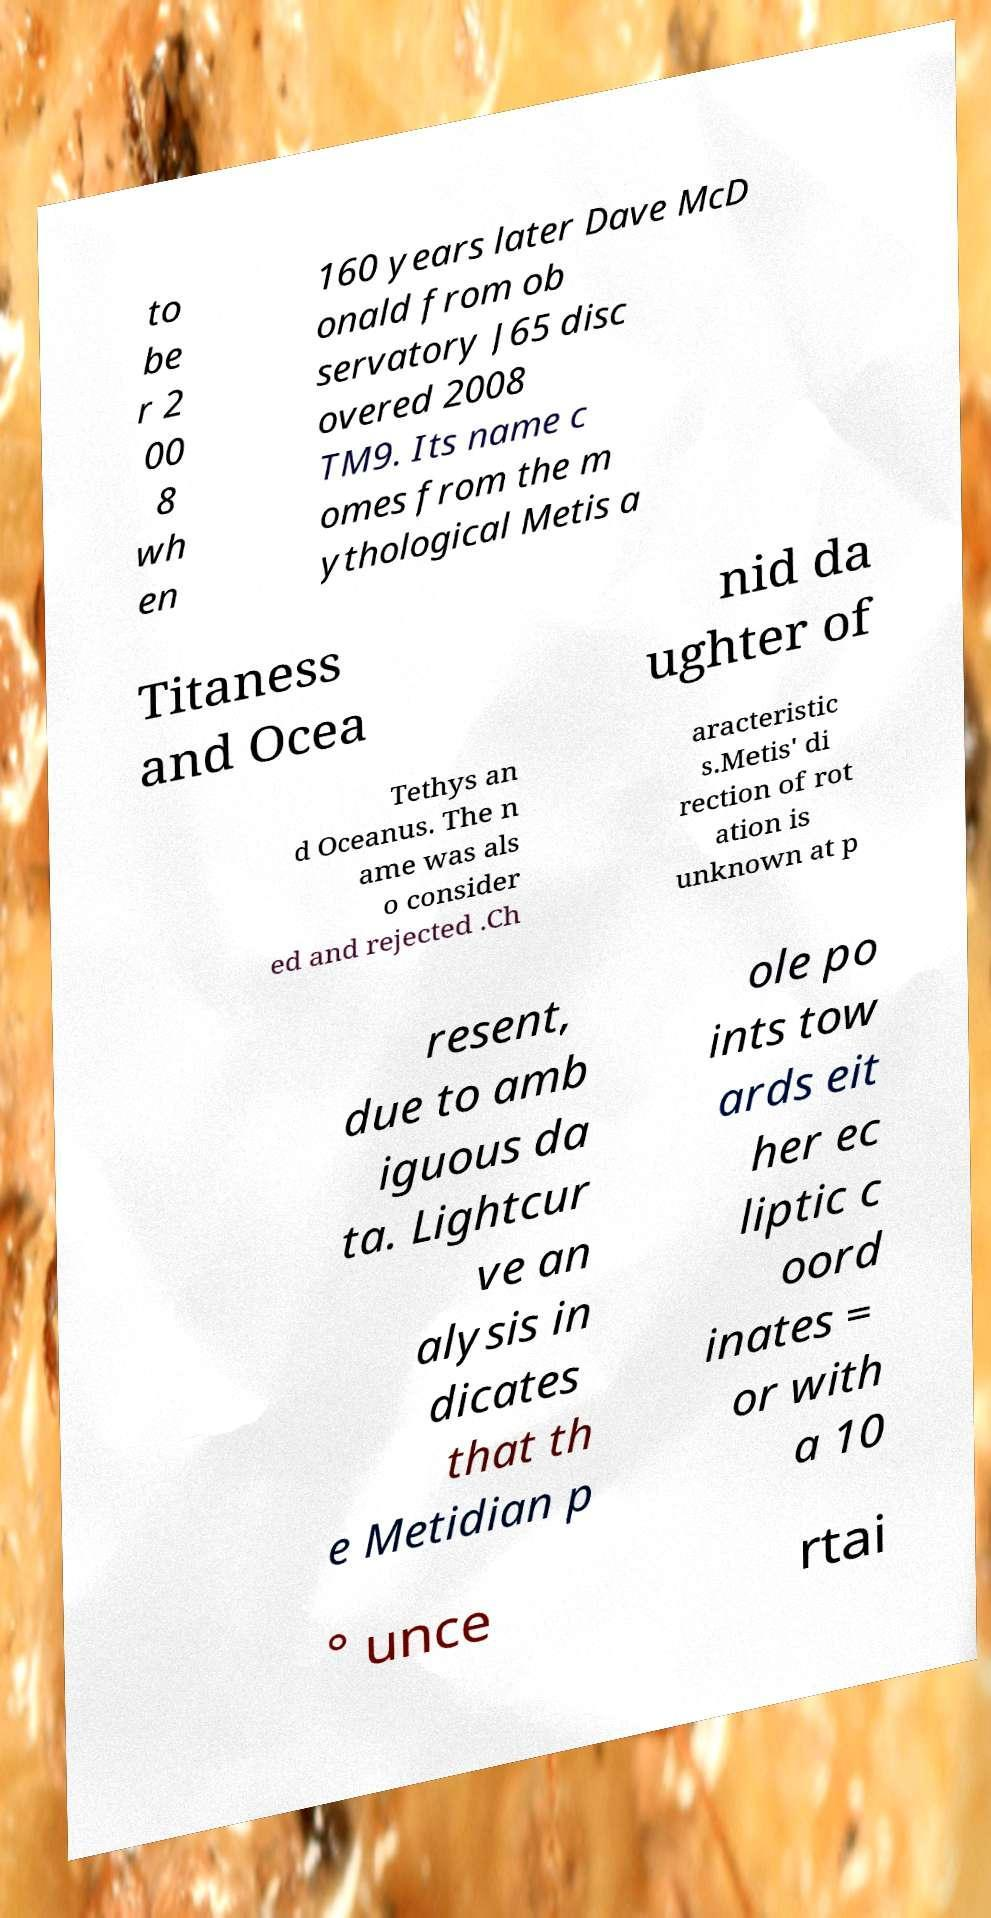Can you accurately transcribe the text from the provided image for me? to be r 2 00 8 wh en 160 years later Dave McD onald from ob servatory J65 disc overed 2008 TM9. Its name c omes from the m ythological Metis a Titaness and Ocea nid da ughter of Tethys an d Oceanus. The n ame was als o consider ed and rejected .Ch aracteristic s.Metis' di rection of rot ation is unknown at p resent, due to amb iguous da ta. Lightcur ve an alysis in dicates that th e Metidian p ole po ints tow ards eit her ec liptic c oord inates = or with a 10 ° unce rtai 